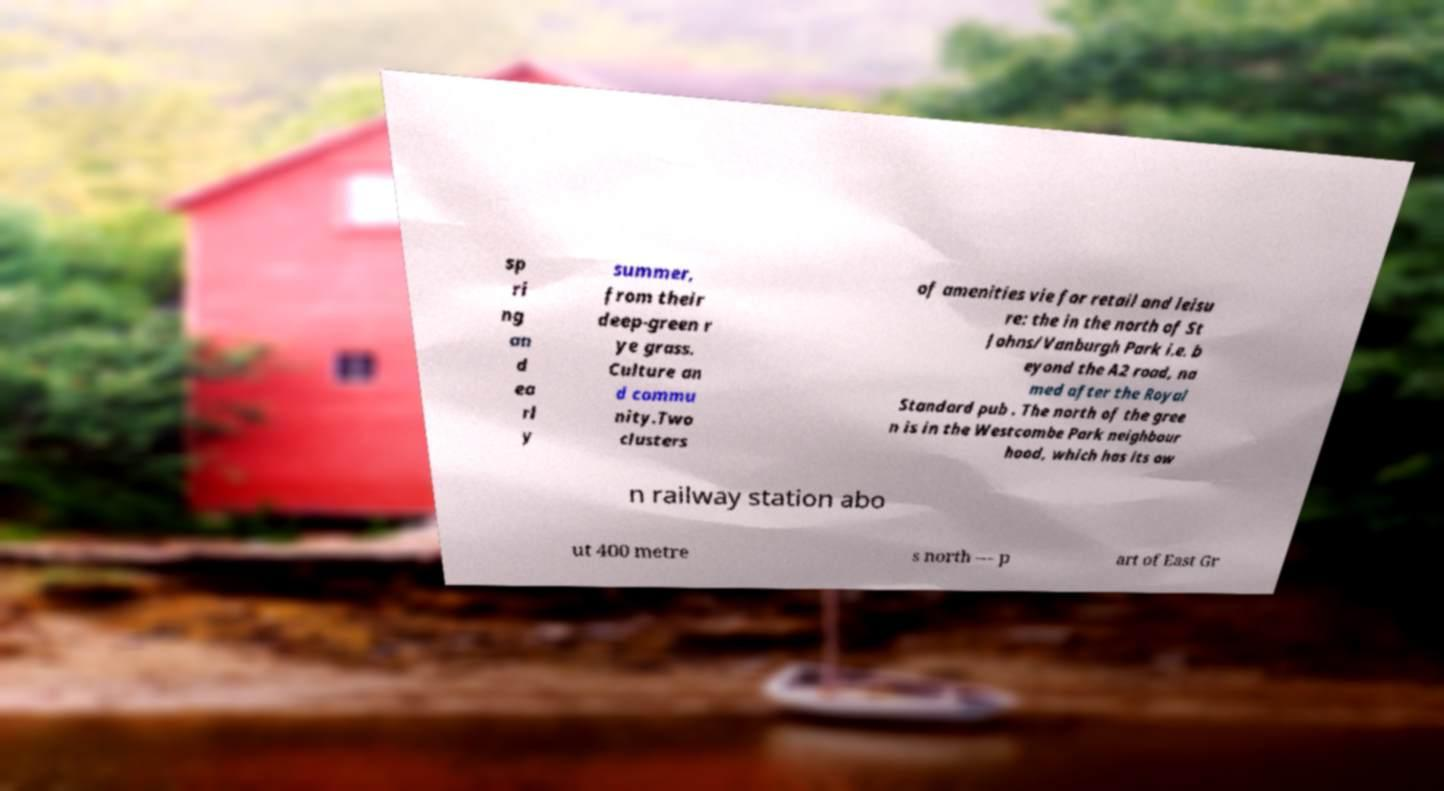Can you accurately transcribe the text from the provided image for me? sp ri ng an d ea rl y summer, from their deep-green r ye grass. Culture an d commu nity.Two clusters of amenities vie for retail and leisu re: the in the north of St Johns/Vanburgh Park i.e. b eyond the A2 road, na med after the Royal Standard pub . The north of the gree n is in the Westcombe Park neighbour hood, which has its ow n railway station abo ut 400 metre s north — p art of East Gr 